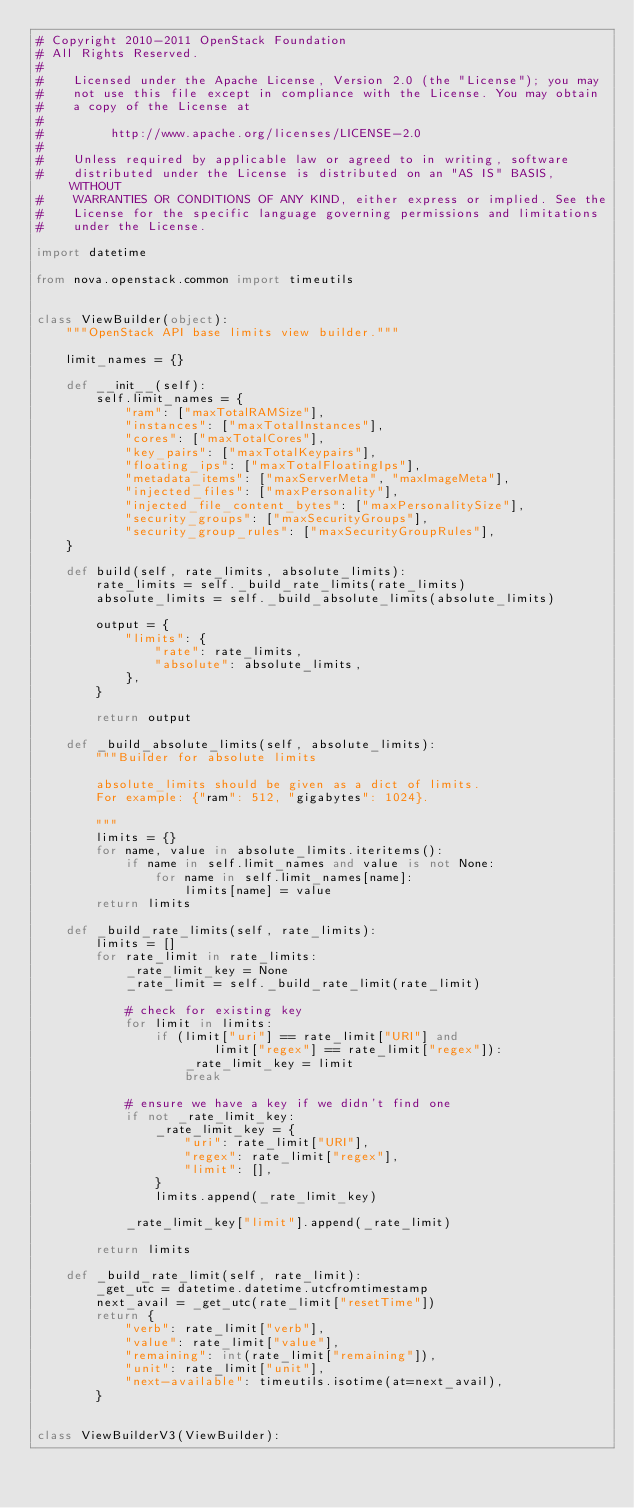Convert code to text. <code><loc_0><loc_0><loc_500><loc_500><_Python_># Copyright 2010-2011 OpenStack Foundation
# All Rights Reserved.
#
#    Licensed under the Apache License, Version 2.0 (the "License"); you may
#    not use this file except in compliance with the License. You may obtain
#    a copy of the License at
#
#         http://www.apache.org/licenses/LICENSE-2.0
#
#    Unless required by applicable law or agreed to in writing, software
#    distributed under the License is distributed on an "AS IS" BASIS, WITHOUT
#    WARRANTIES OR CONDITIONS OF ANY KIND, either express or implied. See the
#    License for the specific language governing permissions and limitations
#    under the License.

import datetime

from nova.openstack.common import timeutils


class ViewBuilder(object):
    """OpenStack API base limits view builder."""

    limit_names = {}

    def __init__(self):
        self.limit_names = {
            "ram": ["maxTotalRAMSize"],
            "instances": ["maxTotalInstances"],
            "cores": ["maxTotalCores"],
            "key_pairs": ["maxTotalKeypairs"],
            "floating_ips": ["maxTotalFloatingIps"],
            "metadata_items": ["maxServerMeta", "maxImageMeta"],
            "injected_files": ["maxPersonality"],
            "injected_file_content_bytes": ["maxPersonalitySize"],
            "security_groups": ["maxSecurityGroups"],
            "security_group_rules": ["maxSecurityGroupRules"],
    }

    def build(self, rate_limits, absolute_limits):
        rate_limits = self._build_rate_limits(rate_limits)
        absolute_limits = self._build_absolute_limits(absolute_limits)

        output = {
            "limits": {
                "rate": rate_limits,
                "absolute": absolute_limits,
            },
        }

        return output

    def _build_absolute_limits(self, absolute_limits):
        """Builder for absolute limits

        absolute_limits should be given as a dict of limits.
        For example: {"ram": 512, "gigabytes": 1024}.

        """
        limits = {}
        for name, value in absolute_limits.iteritems():
            if name in self.limit_names and value is not None:
                for name in self.limit_names[name]:
                    limits[name] = value
        return limits

    def _build_rate_limits(self, rate_limits):
        limits = []
        for rate_limit in rate_limits:
            _rate_limit_key = None
            _rate_limit = self._build_rate_limit(rate_limit)

            # check for existing key
            for limit in limits:
                if (limit["uri"] == rate_limit["URI"] and
                        limit["regex"] == rate_limit["regex"]):
                    _rate_limit_key = limit
                    break

            # ensure we have a key if we didn't find one
            if not _rate_limit_key:
                _rate_limit_key = {
                    "uri": rate_limit["URI"],
                    "regex": rate_limit["regex"],
                    "limit": [],
                }
                limits.append(_rate_limit_key)

            _rate_limit_key["limit"].append(_rate_limit)

        return limits

    def _build_rate_limit(self, rate_limit):
        _get_utc = datetime.datetime.utcfromtimestamp
        next_avail = _get_utc(rate_limit["resetTime"])
        return {
            "verb": rate_limit["verb"],
            "value": rate_limit["value"],
            "remaining": int(rate_limit["remaining"]),
            "unit": rate_limit["unit"],
            "next-available": timeutils.isotime(at=next_avail),
        }


class ViewBuilderV3(ViewBuilder):
</code> 